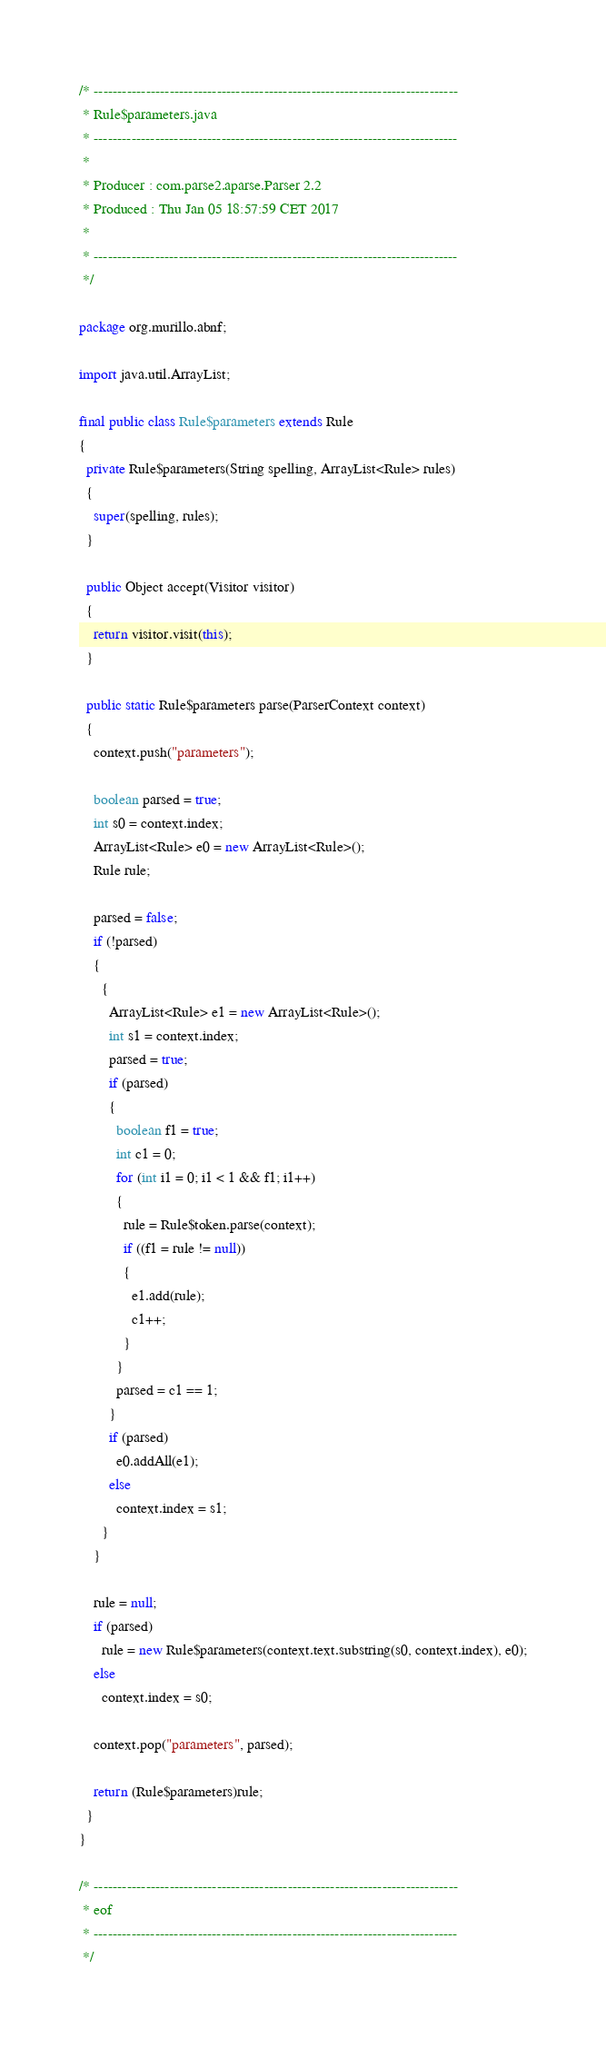Convert code to text. <code><loc_0><loc_0><loc_500><loc_500><_Java_>/* -----------------------------------------------------------------------------
 * Rule$parameters.java
 * -----------------------------------------------------------------------------
 *
 * Producer : com.parse2.aparse.Parser 2.2
 * Produced : Thu Jan 05 18:57:59 CET 2017
 *
 * -----------------------------------------------------------------------------
 */

package org.murillo.abnf;

import java.util.ArrayList;

final public class Rule$parameters extends Rule
{
  private Rule$parameters(String spelling, ArrayList<Rule> rules)
  {
    super(spelling, rules);
  }

  public Object accept(Visitor visitor)
  {
    return visitor.visit(this);
  }

  public static Rule$parameters parse(ParserContext context)
  {
    context.push("parameters");

    boolean parsed = true;
    int s0 = context.index;
    ArrayList<Rule> e0 = new ArrayList<Rule>();
    Rule rule;

    parsed = false;
    if (!parsed)
    {
      {
        ArrayList<Rule> e1 = new ArrayList<Rule>();
        int s1 = context.index;
        parsed = true;
        if (parsed)
        {
          boolean f1 = true;
          int c1 = 0;
          for (int i1 = 0; i1 < 1 && f1; i1++)
          {
            rule = Rule$token.parse(context);
            if ((f1 = rule != null))
            {
              e1.add(rule);
              c1++;
            }
          }
          parsed = c1 == 1;
        }
        if (parsed)
          e0.addAll(e1);
        else
          context.index = s1;
      }
    }

    rule = null;
    if (parsed)
      rule = new Rule$parameters(context.text.substring(s0, context.index), e0);
    else
      context.index = s0;

    context.pop("parameters", parsed);

    return (Rule$parameters)rule;
  }
}

/* -----------------------------------------------------------------------------
 * eof
 * -----------------------------------------------------------------------------
 */
</code> 